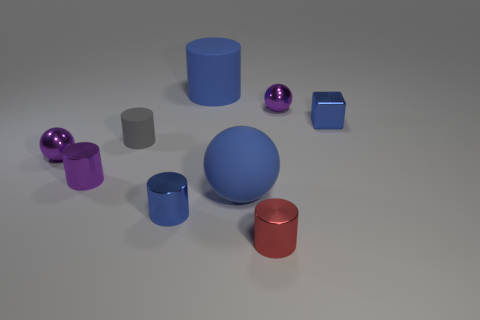There is a purple thing that is the same shape as the red object; what is its size?
Your answer should be very brief. Small. Is the number of small blue cubes that are behind the metal cube less than the number of small red things?
Ensure brevity in your answer.  Yes. Is there a tiny purple metal cylinder?
Your response must be concise. Yes. There is a large rubber thing that is the same shape as the red metallic thing; what color is it?
Your answer should be compact. Blue. Do the large object that is in front of the tiny purple metal cylinder and the metal cube have the same color?
Make the answer very short. Yes. Does the shiny cube have the same size as the red shiny cylinder?
Ensure brevity in your answer.  Yes. There is a small red object that is made of the same material as the purple cylinder; what shape is it?
Offer a very short reply. Cylinder. What number of other things are there of the same shape as the gray matte object?
Make the answer very short. 4. What shape is the large object behind the tiny blue shiny thing that is behind the blue cylinder in front of the blue cube?
Offer a terse response. Cylinder. How many cylinders are either red metallic things or big rubber things?
Give a very brief answer. 2. 